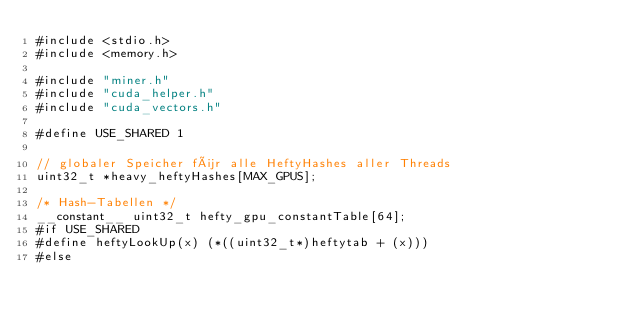Convert code to text. <code><loc_0><loc_0><loc_500><loc_500><_Cuda_>#include <stdio.h>
#include <memory.h>

#include "miner.h"
#include "cuda_helper.h"
#include "cuda_vectors.h"

#define USE_SHARED 1

// globaler Speicher für alle HeftyHashes aller Threads
uint32_t *heavy_heftyHashes[MAX_GPUS];

/* Hash-Tabellen */
__constant__ uint32_t hefty_gpu_constantTable[64];
#if USE_SHARED
#define heftyLookUp(x) (*((uint32_t*)heftytab + (x)))
#else</code> 